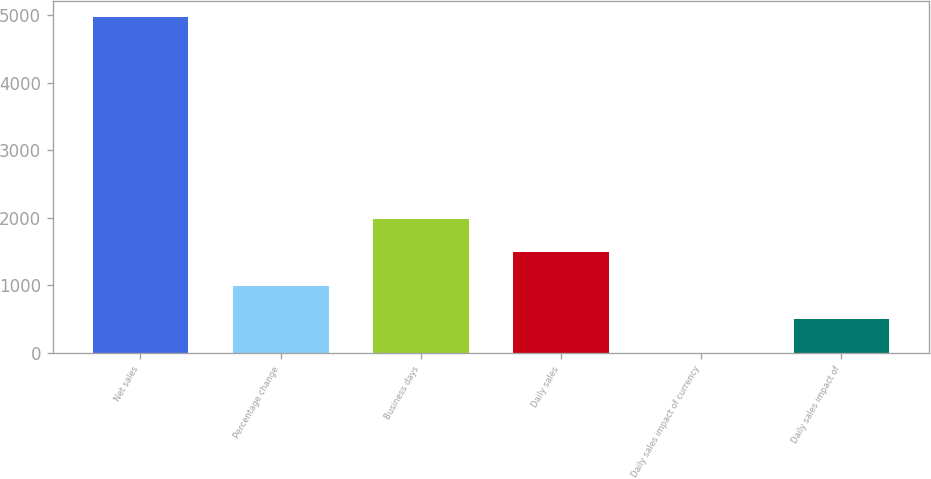Convert chart. <chart><loc_0><loc_0><loc_500><loc_500><bar_chart><fcel>Net sales<fcel>Percentage change<fcel>Business days<fcel>Daily sales<fcel>Daily sales impact of currency<fcel>Daily sales impact of<nl><fcel>4965.1<fcel>993.1<fcel>1986.1<fcel>1489.6<fcel>0.1<fcel>496.6<nl></chart> 